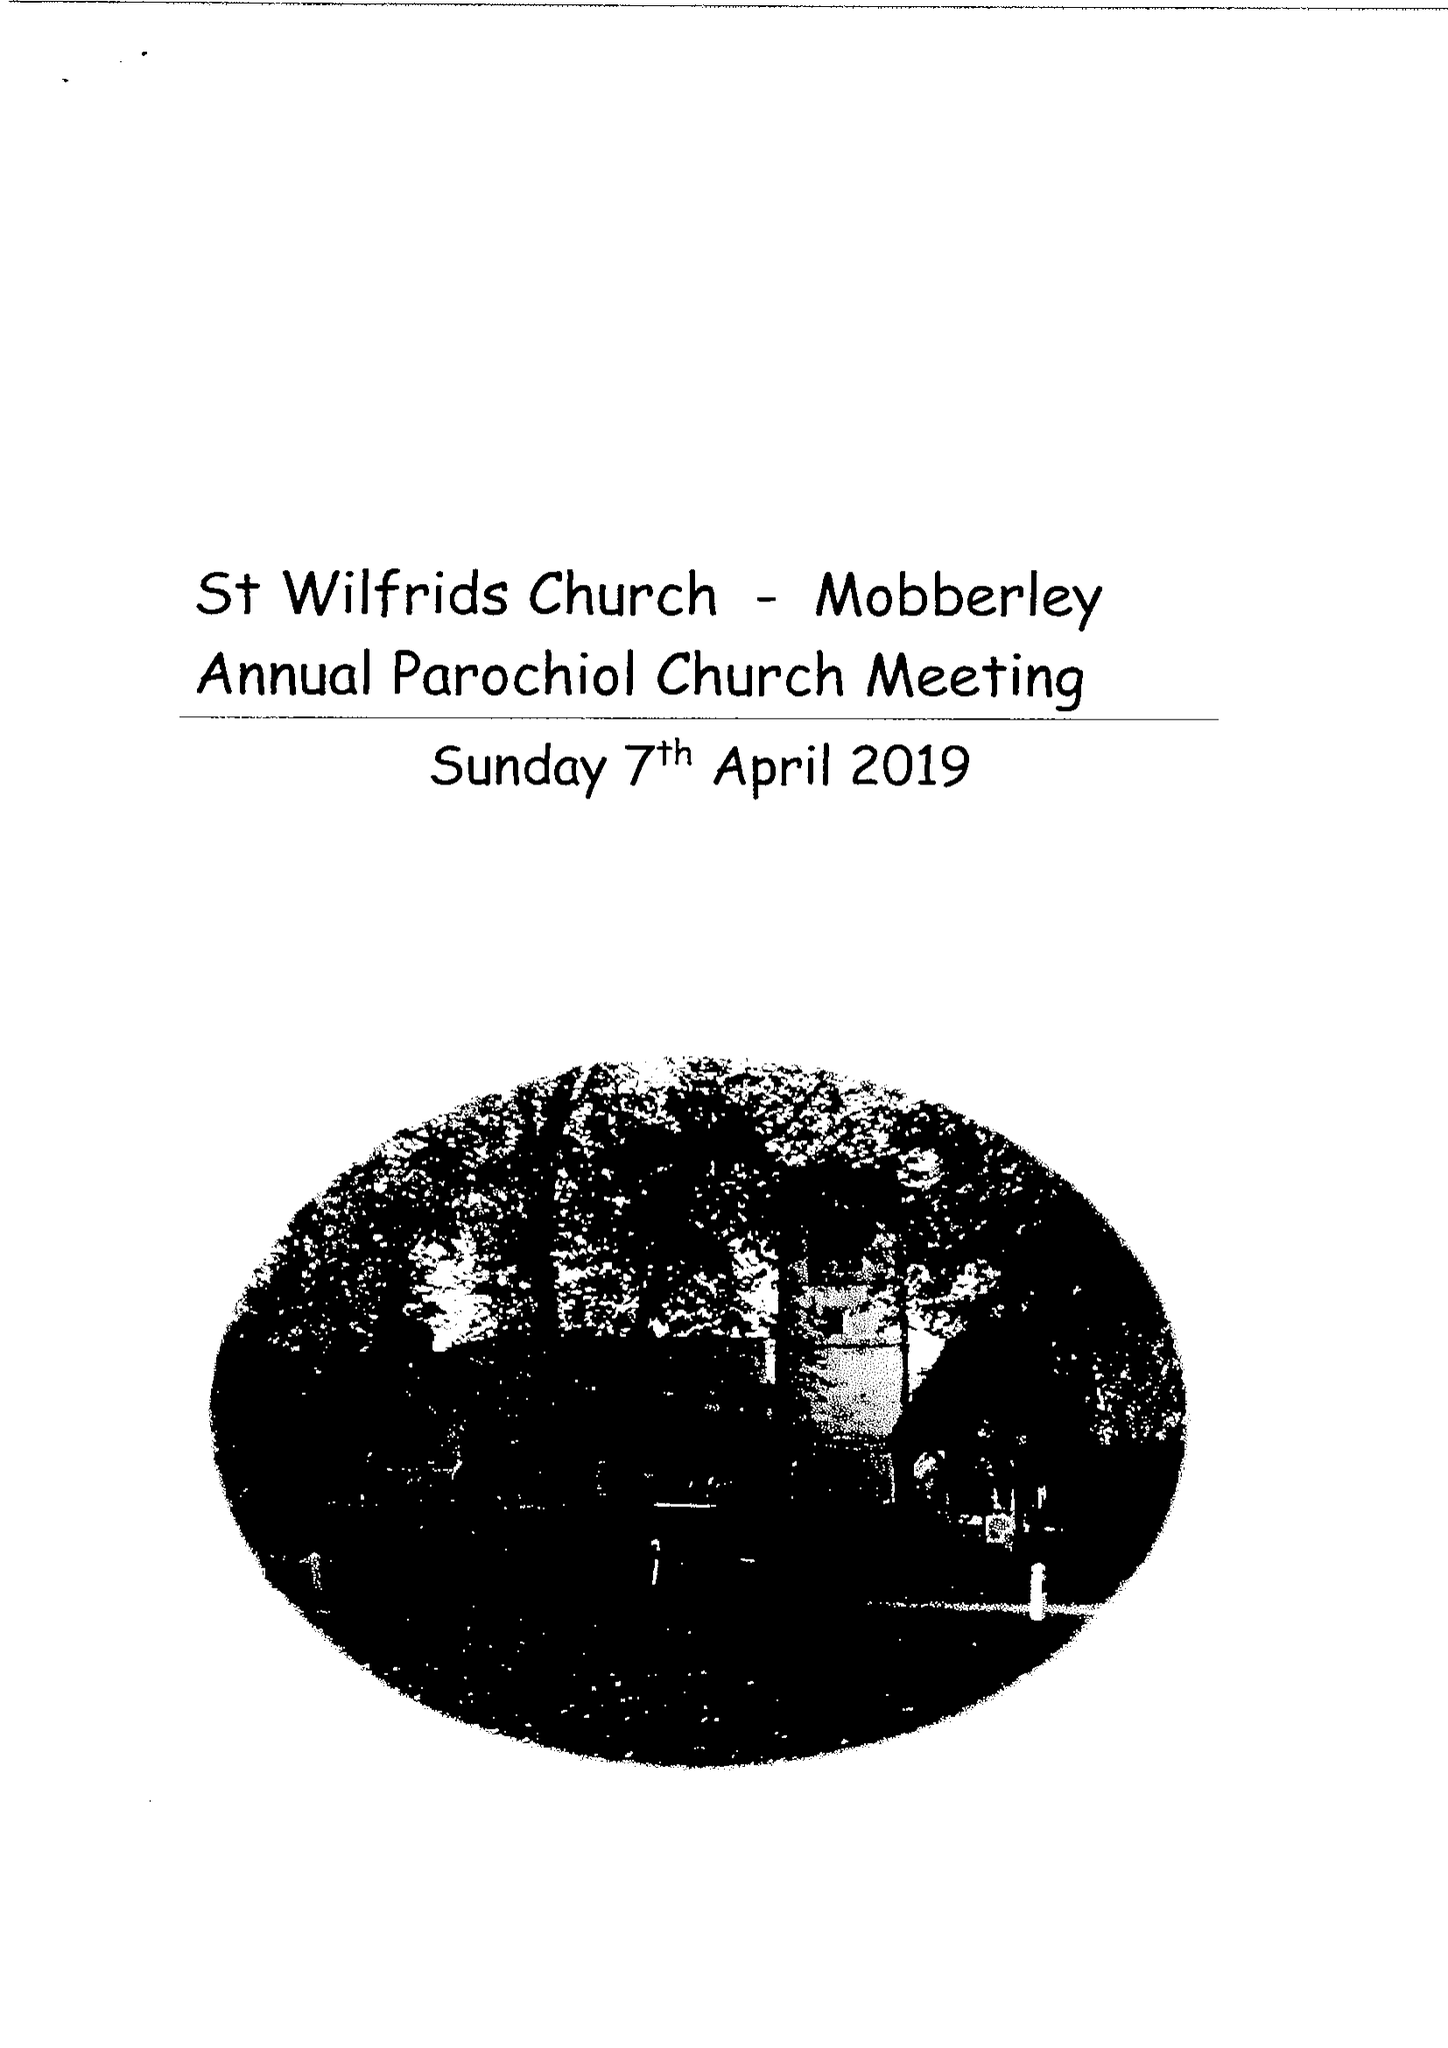What is the value for the address__street_line?
Answer the question using a single word or phrase. None 